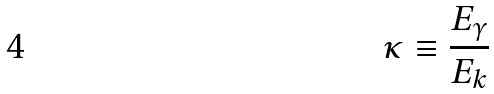Convert formula to latex. <formula><loc_0><loc_0><loc_500><loc_500>\kappa \equiv \frac { E _ { \gamma } } { E _ { k } }</formula> 